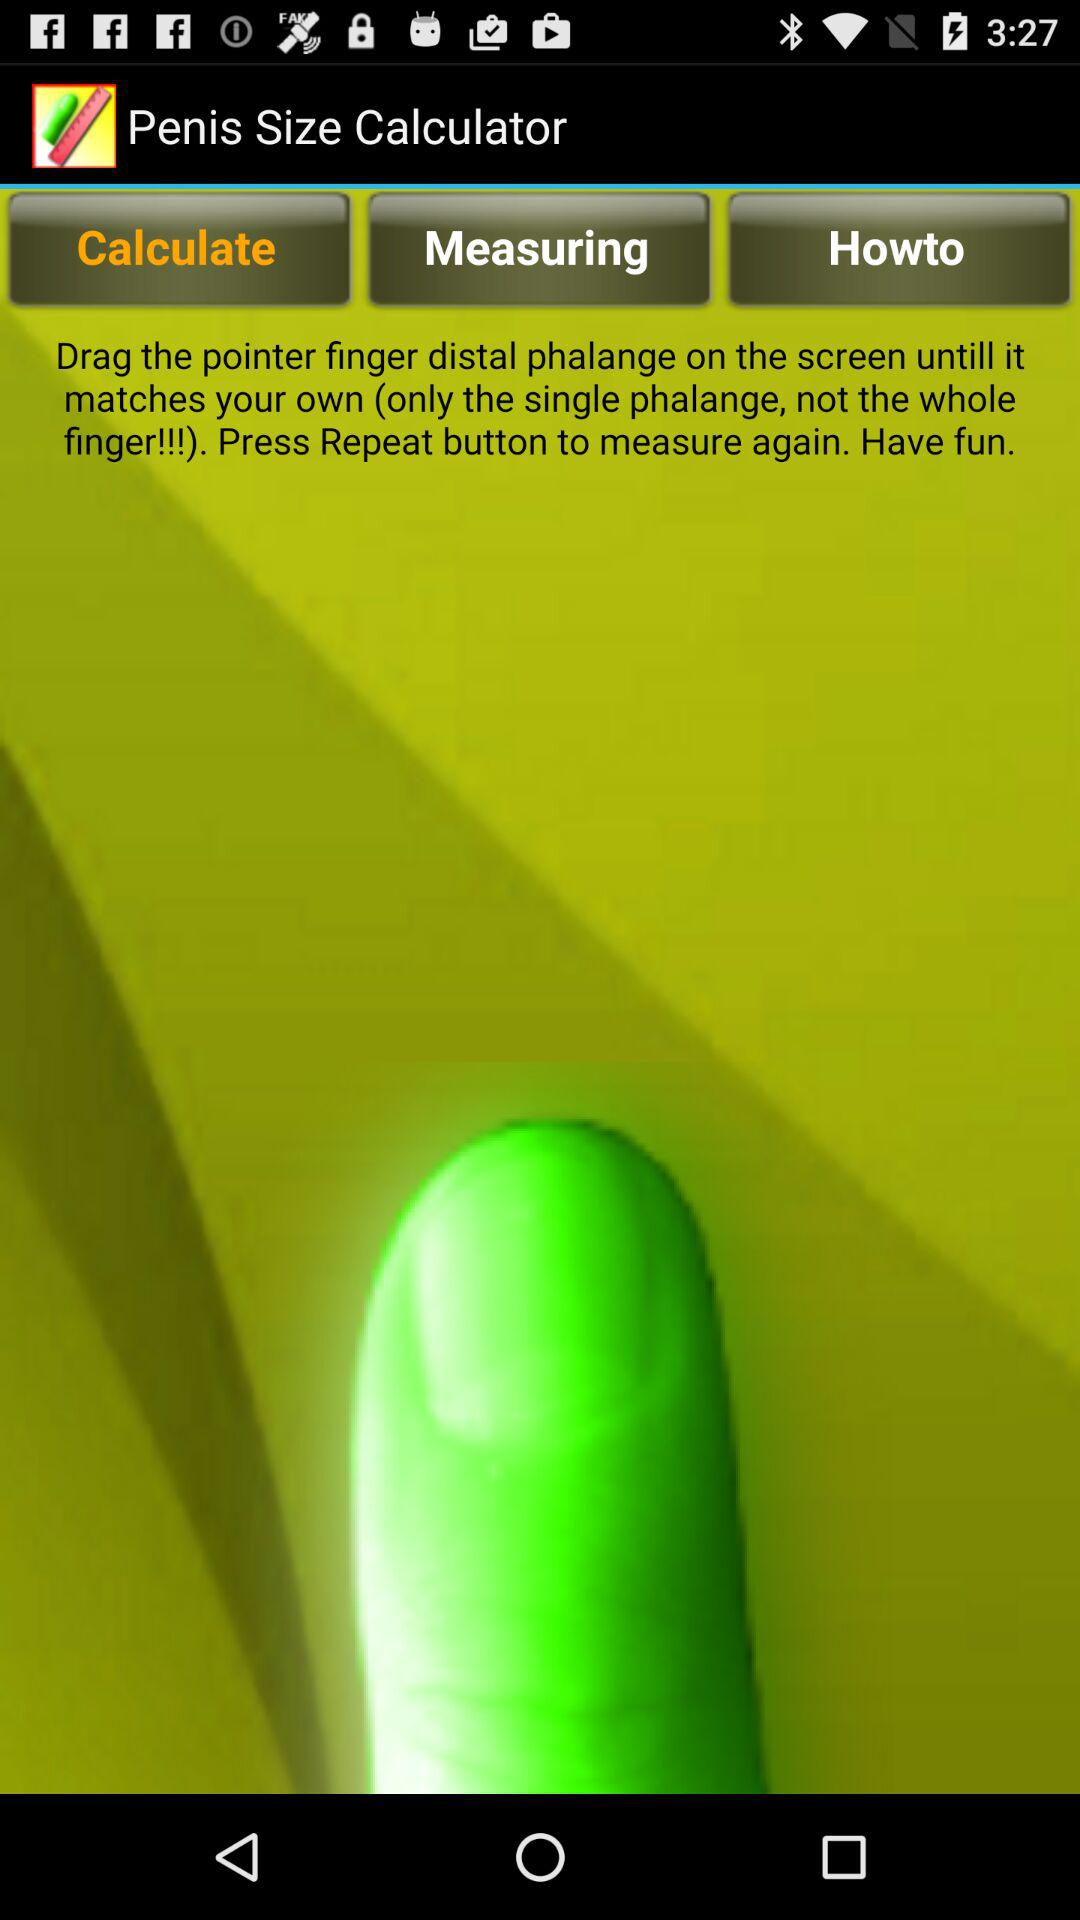What is the application name? The application name is "Penis Size Calculator". 